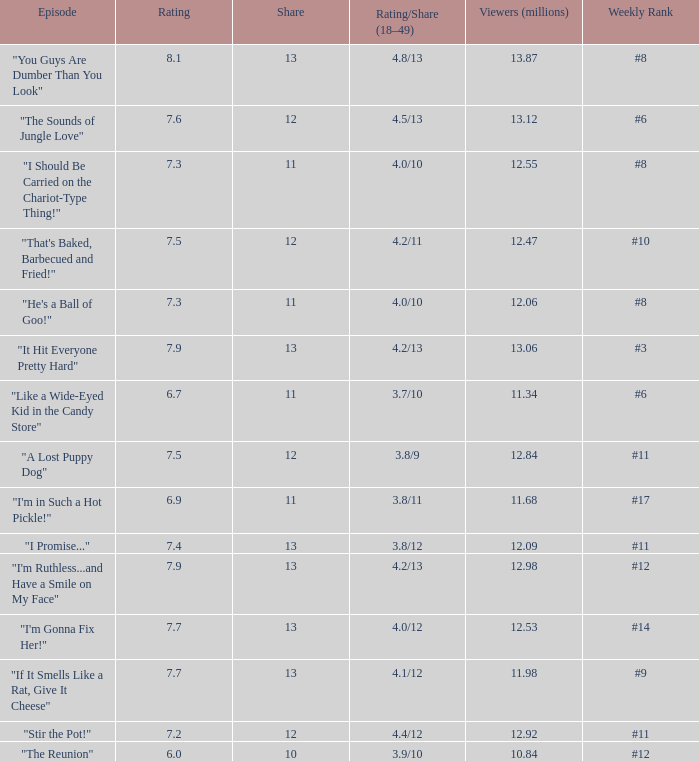What is the mean score for "a lost puppy dog"? 7.5. 